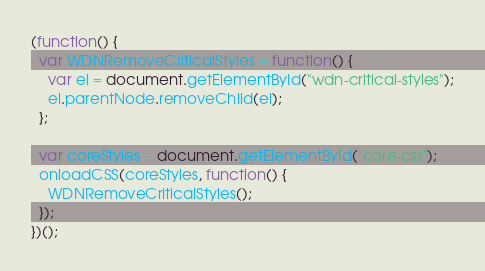Convert code to text. <code><loc_0><loc_0><loc_500><loc_500><_JavaScript_>(function() {
  var WDNRemoveCriticalStyles = function() {
    var el = document.getElementById("wdn-critical-styles");
    el.parentNode.removeChild(el);
  };

  var coreStyles = document.getElementById("core-css");
  onloadCSS(coreStyles, function() {
    WDNRemoveCriticalStyles();
  });
})();
</code> 